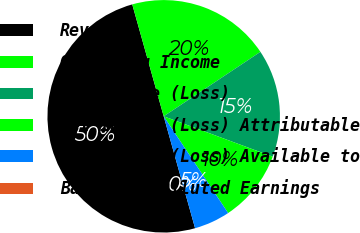Convert chart to OTSL. <chart><loc_0><loc_0><loc_500><loc_500><pie_chart><fcel>Revenues<fcel>Operating Income<fcel>Net Income (Loss)<fcel>Net Income (Loss) Attributable<fcel>Net Income (Loss) Available to<fcel>Basic and Diluted Earnings<nl><fcel>49.99%<fcel>20.0%<fcel>15.0%<fcel>10.0%<fcel>5.0%<fcel>0.0%<nl></chart> 